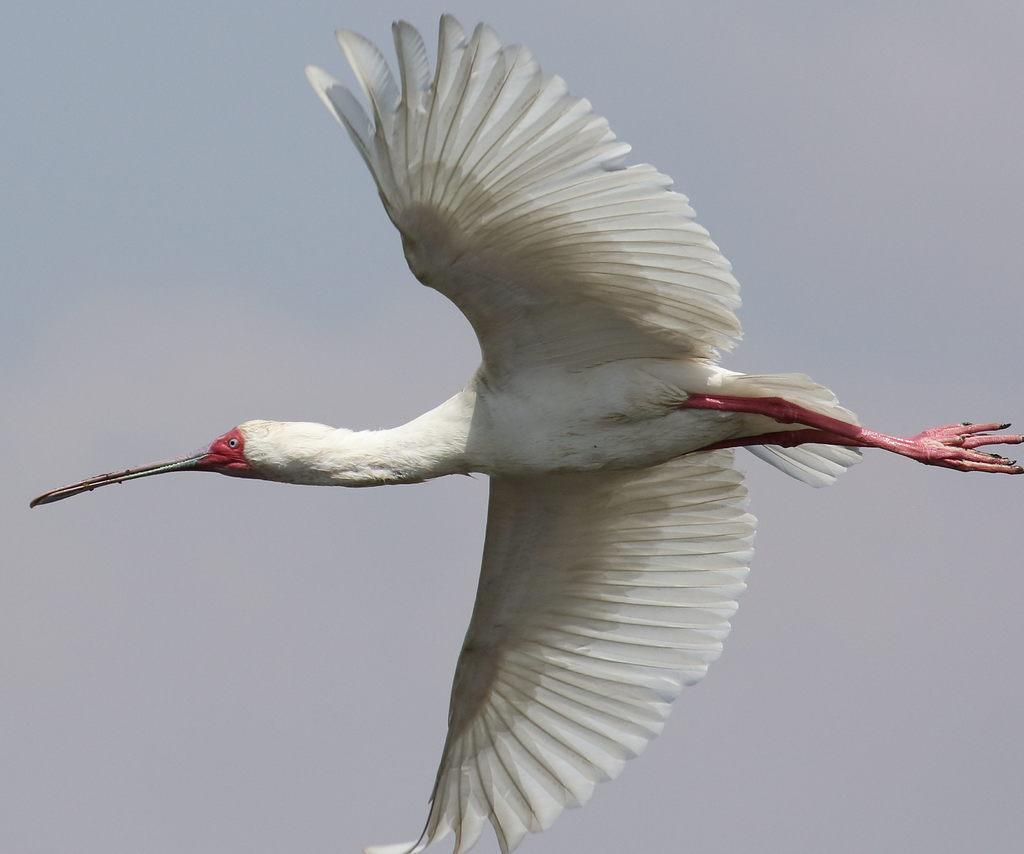Please provide a concise description of this image. A white bird is flying in the sky towards the left. It has a long beak. 